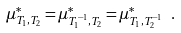Convert formula to latex. <formula><loc_0><loc_0><loc_500><loc_500>\mu ^ { * } _ { T _ { 1 } , T _ { 2 } } = \mu ^ { * } _ { T _ { 1 } ^ { - 1 } , T _ { 2 } } = \mu ^ { * } _ { T _ { 1 } , T _ { 2 } ^ { - 1 } } \ .</formula> 